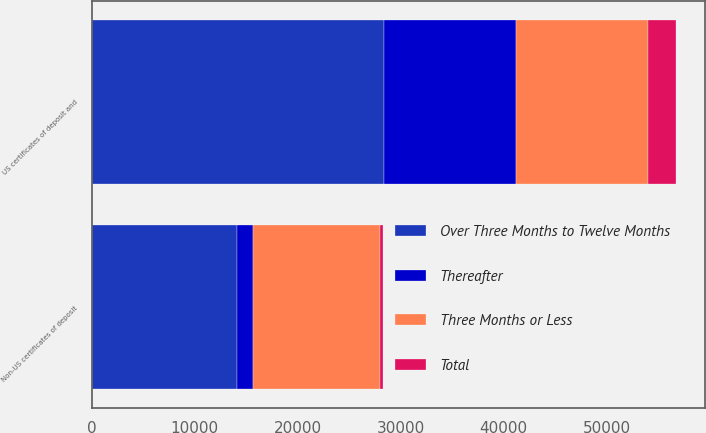Convert chart. <chart><loc_0><loc_0><loc_500><loc_500><stacked_bar_chart><ecel><fcel>US certificates of deposit and<fcel>Non-US certificates of deposit<nl><fcel>Three Months or Less<fcel>12836<fcel>12352<nl><fcel>Thereafter<fcel>12834<fcel>1517<nl><fcel>Total<fcel>2677<fcel>277<nl><fcel>Over Three Months to Twelve Months<fcel>28347<fcel>14146<nl></chart> 